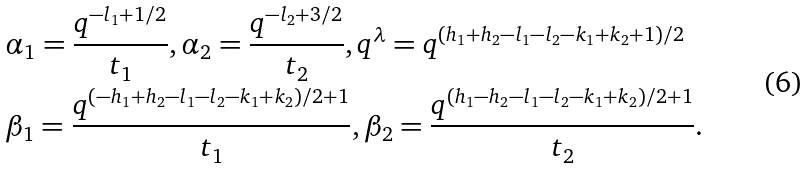Convert formula to latex. <formula><loc_0><loc_0><loc_500><loc_500>& \alpha _ { 1 } = \frac { q ^ { - l _ { 1 } + 1 / 2 } } { t _ { 1 } } , \alpha _ { 2 } = \frac { q ^ { - l _ { 2 } + 3 / 2 } } { t _ { 2 } } , q ^ { \lambda } = q ^ { ( h _ { 1 } + h _ { 2 } - l _ { 1 } - l _ { 2 } - k _ { 1 } + k _ { 2 } + 1 ) / 2 } \\ & \beta _ { 1 } = \frac { q ^ { ( - h _ { 1 } + h _ { 2 } - l _ { 1 } - l _ { 2 } - k _ { 1 } + k _ { 2 } ) / 2 + 1 } } { t _ { 1 } } , \beta _ { 2 } = \frac { q ^ { ( h _ { 1 } - h _ { 2 } - l _ { 1 } - l _ { 2 } - k _ { 1 } + k _ { 2 } ) / 2 + 1 } } { t _ { 2 } } .</formula> 